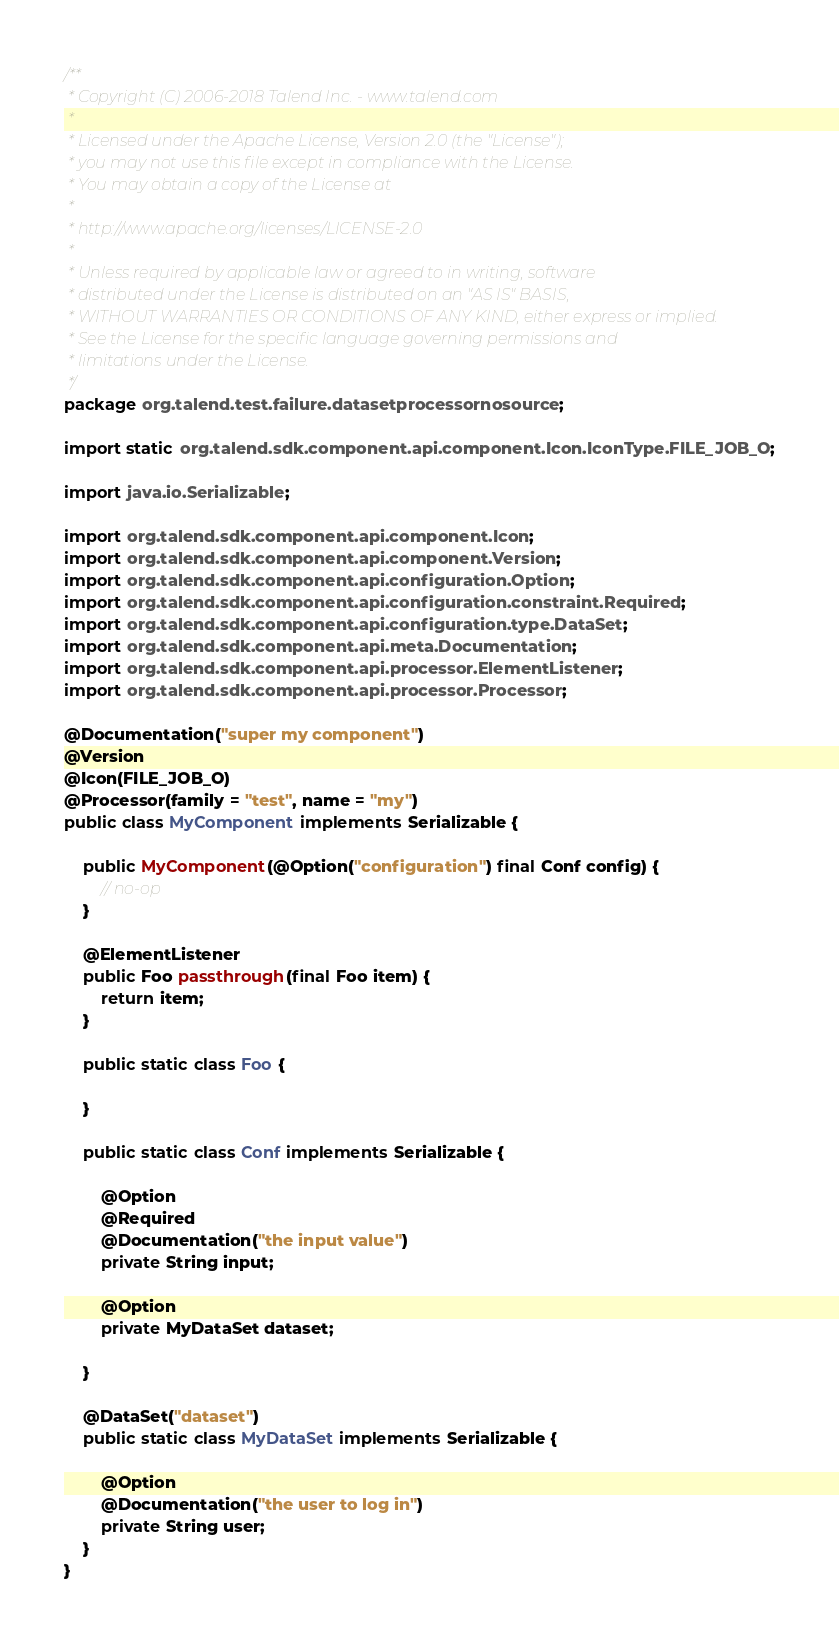<code> <loc_0><loc_0><loc_500><loc_500><_Java_>/**
 * Copyright (C) 2006-2018 Talend Inc. - www.talend.com
 *
 * Licensed under the Apache License, Version 2.0 (the "License");
 * you may not use this file except in compliance with the License.
 * You may obtain a copy of the License at
 *
 * http://www.apache.org/licenses/LICENSE-2.0
 *
 * Unless required by applicable law or agreed to in writing, software
 * distributed under the License is distributed on an "AS IS" BASIS,
 * WITHOUT WARRANTIES OR CONDITIONS OF ANY KIND, either express or implied.
 * See the License for the specific language governing permissions and
 * limitations under the License.
 */
package org.talend.test.failure.datasetprocessornosource;

import static org.talend.sdk.component.api.component.Icon.IconType.FILE_JOB_O;

import java.io.Serializable;

import org.talend.sdk.component.api.component.Icon;
import org.talend.sdk.component.api.component.Version;
import org.talend.sdk.component.api.configuration.Option;
import org.talend.sdk.component.api.configuration.constraint.Required;
import org.talend.sdk.component.api.configuration.type.DataSet;
import org.talend.sdk.component.api.meta.Documentation;
import org.talend.sdk.component.api.processor.ElementListener;
import org.talend.sdk.component.api.processor.Processor;

@Documentation("super my component")
@Version
@Icon(FILE_JOB_O)
@Processor(family = "test", name = "my")
public class MyComponent implements Serializable {

    public MyComponent(@Option("configuration") final Conf config) {
        // no-op
    }

    @ElementListener
    public Foo passthrough(final Foo item) {
        return item;
    }

    public static class Foo {

    }

    public static class Conf implements Serializable {

        @Option
        @Required
        @Documentation("the input value")
        private String input;

        @Option
        private MyDataSet dataset;

    }

    @DataSet("dataset")
    public static class MyDataSet implements Serializable {

        @Option
        @Documentation("the user to log in")
        private String user;
    }
}
</code> 